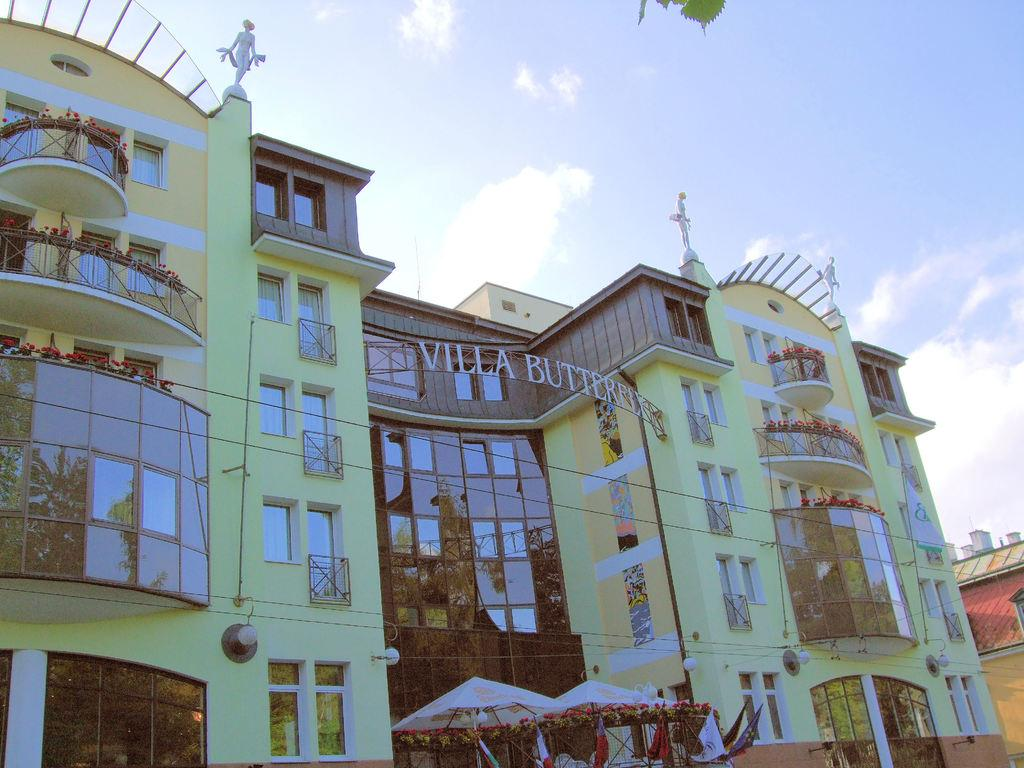What is the main structure in the center of the image? There is a building in the center of the image. What type of temporary shelters can be seen at the bottom of the image? There are tents at the bottom of the image. What can be seen in the background of the image? The sky is visible in the background of the image. What type of weather condition is suggested by the presence of clouds in the background? Clouds are present in the background of the image, suggesting a partly cloudy or overcast day. What type of business advice can be seen on the building in the image? There is no business advice visible on the building in the image; it is simply a structure with no text or information about businesses or advice. 